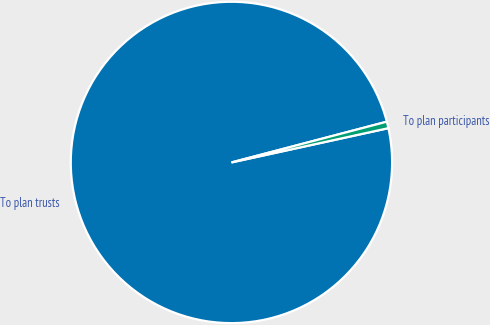<chart> <loc_0><loc_0><loc_500><loc_500><pie_chart><fcel>To plan trusts<fcel>To plan participants<nl><fcel>99.34%<fcel>0.66%<nl></chart> 